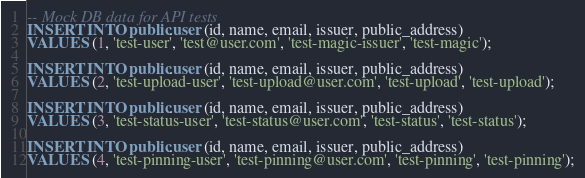<code> <loc_0><loc_0><loc_500><loc_500><_SQL_>-- Mock DB data for API tests
INSERT INTO public.user (id, name, email, issuer, public_address)
VALUES (1, 'test-user', 'test@user.com', 'test-magic-issuer', 'test-magic');

INSERT INTO public.user (id, name, email, issuer, public_address)
VALUES (2, 'test-upload-user', 'test-upload@user.com', 'test-upload', 'test-upload');

INSERT INTO public.user (id, name, email, issuer, public_address)
VALUES (3, 'test-status-user', 'test-status@user.com', 'test-status', 'test-status');

INSERT INTO public.user (id, name, email, issuer, public_address)
VALUES (4, 'test-pinning-user', 'test-pinning@user.com', 'test-pinning', 'test-pinning');
</code> 